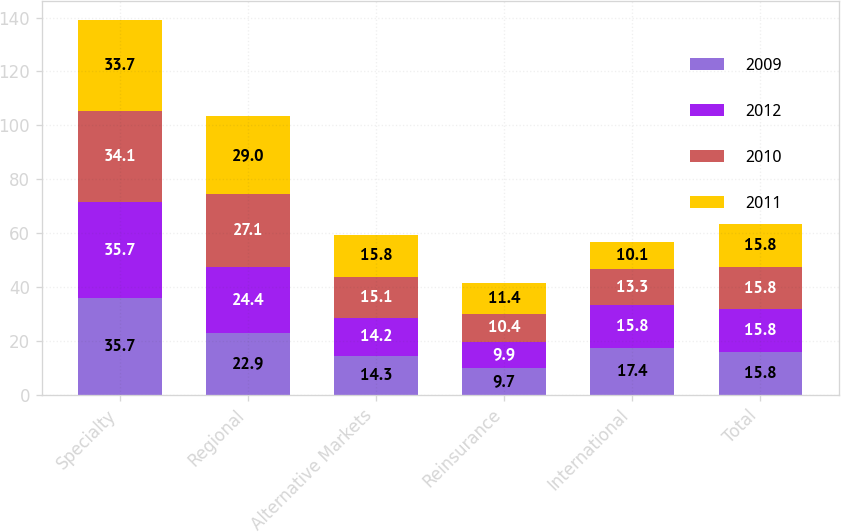Convert chart. <chart><loc_0><loc_0><loc_500><loc_500><stacked_bar_chart><ecel><fcel>Specialty<fcel>Regional<fcel>Alternative Markets<fcel>Reinsurance<fcel>International<fcel>Total<nl><fcel>2009<fcel>35.7<fcel>22.9<fcel>14.3<fcel>9.7<fcel>17.4<fcel>15.8<nl><fcel>2012<fcel>35.7<fcel>24.4<fcel>14.2<fcel>9.9<fcel>15.8<fcel>15.8<nl><fcel>2010<fcel>34.1<fcel>27.1<fcel>15.1<fcel>10.4<fcel>13.3<fcel>15.8<nl><fcel>2011<fcel>33.7<fcel>29<fcel>15.8<fcel>11.4<fcel>10.1<fcel>15.8<nl></chart> 